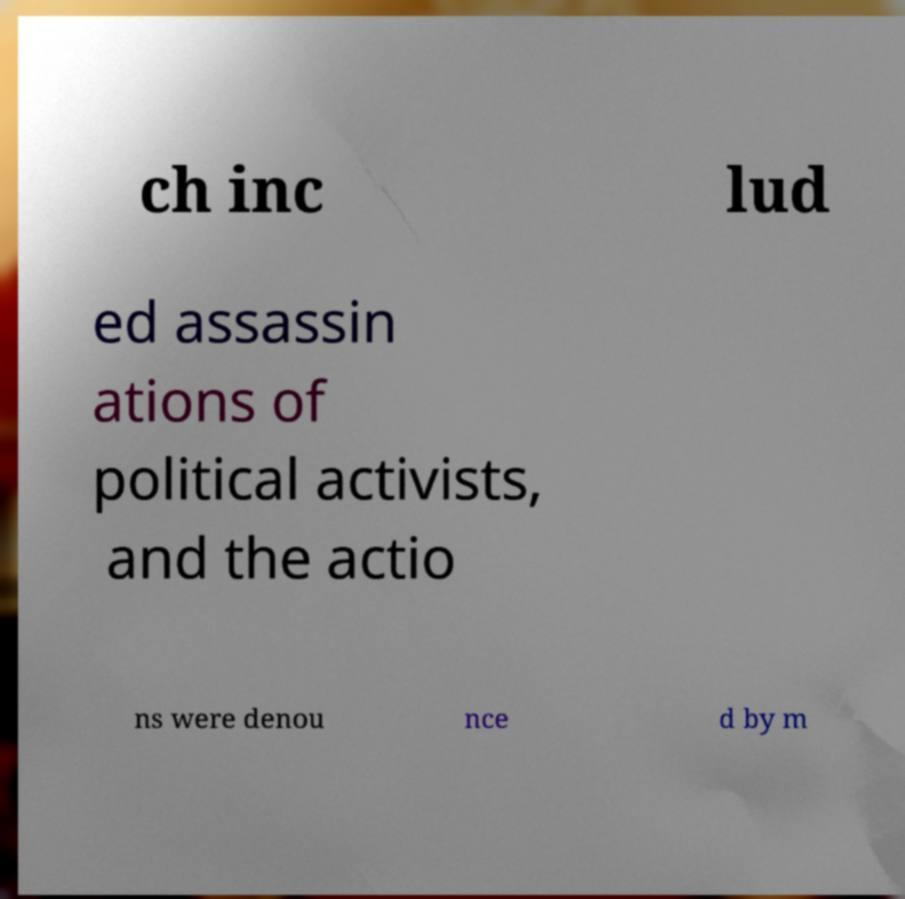For documentation purposes, I need the text within this image transcribed. Could you provide that? ch inc lud ed assassin ations of political activists, and the actio ns were denou nce d by m 